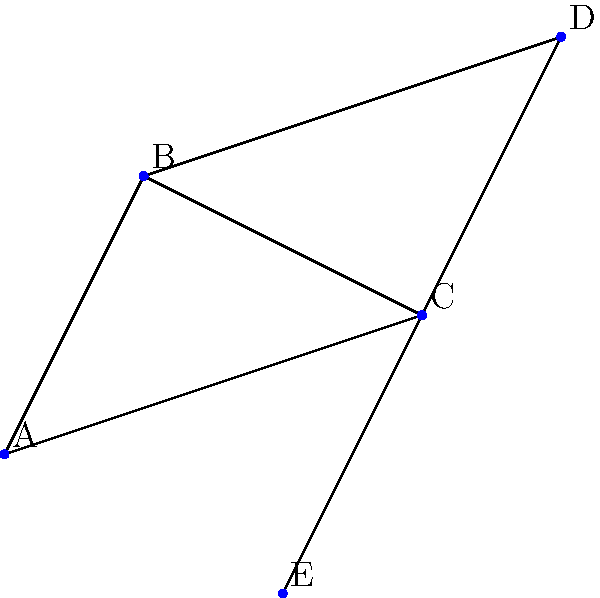In the given network of coastal settlements, what is the minimum number of trade routes that need to be established to ensure all settlements are connected, while maximizing the efficiency of the trade network? To solve this problem, we need to find the minimum spanning tree of the given network. This will ensure all settlements are connected with the minimum number of trade routes, maximizing efficiency. Let's follow these steps:

1. Identify the vertices (settlements) and edges (potential trade routes):
   Vertices: A, B, C, D, E
   Edges: AB, AC, BC, BD, CD, CE, DE

2. Apply Kruskal's algorithm to find the minimum spanning tree:
   a) Sort the edges by their length (visually estimated):
      AC, CE, BC, AB, CD, DE, BD

   b) Add edges to the tree, skipping those that would create a cycle:
      - Add AC
      - Add CE
      - Add BC
      - Add AB
      - Skip CD (creates a cycle)
      - Skip DE (creates a cycle)
      - Skip BD (creates a cycle)

3. The resulting minimum spanning tree consists of 4 edges:
   AC, CE, BC, AB

This minimum spanning tree connects all 5 settlements with the fewest number of trade routes, ensuring maximum efficiency in the trade network.
Answer: 4 